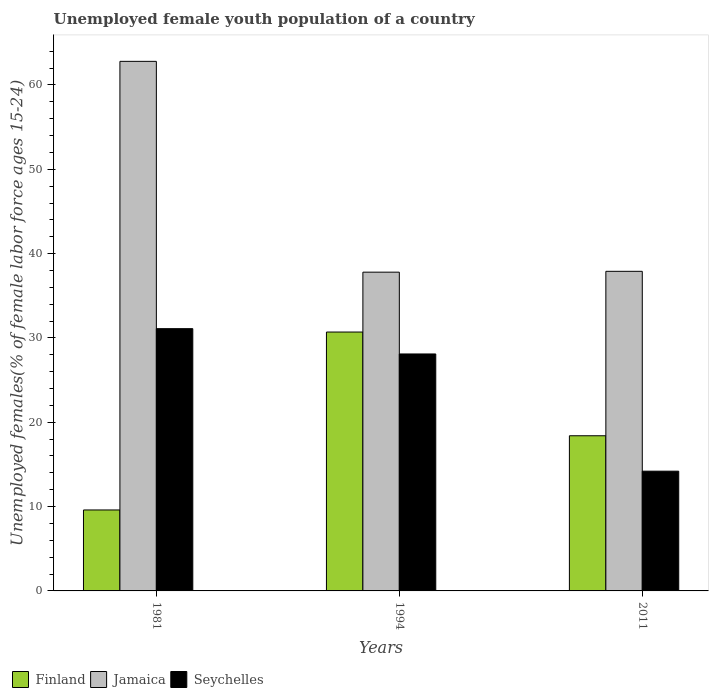How many bars are there on the 1st tick from the right?
Provide a short and direct response. 3. What is the label of the 2nd group of bars from the left?
Your answer should be compact. 1994. What is the percentage of unemployed female youth population in Finland in 1994?
Your answer should be compact. 30.7. Across all years, what is the maximum percentage of unemployed female youth population in Jamaica?
Your answer should be compact. 62.8. Across all years, what is the minimum percentage of unemployed female youth population in Jamaica?
Your response must be concise. 37.8. In which year was the percentage of unemployed female youth population in Jamaica maximum?
Make the answer very short. 1981. In which year was the percentage of unemployed female youth population in Finland minimum?
Give a very brief answer. 1981. What is the total percentage of unemployed female youth population in Jamaica in the graph?
Ensure brevity in your answer.  138.5. What is the difference between the percentage of unemployed female youth population in Finland in 1981 and that in 1994?
Provide a short and direct response. -21.1. What is the difference between the percentage of unemployed female youth population in Finland in 2011 and the percentage of unemployed female youth population in Jamaica in 1981?
Your response must be concise. -44.4. What is the average percentage of unemployed female youth population in Seychelles per year?
Ensure brevity in your answer.  24.47. In the year 1994, what is the difference between the percentage of unemployed female youth population in Seychelles and percentage of unemployed female youth population in Jamaica?
Provide a short and direct response. -9.7. In how many years, is the percentage of unemployed female youth population in Finland greater than 26 %?
Your response must be concise. 1. What is the ratio of the percentage of unemployed female youth population in Seychelles in 1981 to that in 1994?
Your response must be concise. 1.11. What is the difference between the highest and the second highest percentage of unemployed female youth population in Seychelles?
Provide a succinct answer. 3. What is the difference between the highest and the lowest percentage of unemployed female youth population in Finland?
Your answer should be very brief. 21.1. Is the sum of the percentage of unemployed female youth population in Finland in 1994 and 2011 greater than the maximum percentage of unemployed female youth population in Seychelles across all years?
Provide a short and direct response. Yes. What does the 2nd bar from the right in 2011 represents?
Ensure brevity in your answer.  Jamaica. Are the values on the major ticks of Y-axis written in scientific E-notation?
Ensure brevity in your answer.  No. Where does the legend appear in the graph?
Provide a short and direct response. Bottom left. What is the title of the graph?
Offer a very short reply. Unemployed female youth population of a country. What is the label or title of the X-axis?
Your answer should be very brief. Years. What is the label or title of the Y-axis?
Provide a short and direct response. Unemployed females(% of female labor force ages 15-24). What is the Unemployed females(% of female labor force ages 15-24) of Finland in 1981?
Your response must be concise. 9.6. What is the Unemployed females(% of female labor force ages 15-24) of Jamaica in 1981?
Keep it short and to the point. 62.8. What is the Unemployed females(% of female labor force ages 15-24) in Seychelles in 1981?
Your response must be concise. 31.1. What is the Unemployed females(% of female labor force ages 15-24) of Finland in 1994?
Your answer should be compact. 30.7. What is the Unemployed females(% of female labor force ages 15-24) in Jamaica in 1994?
Your answer should be very brief. 37.8. What is the Unemployed females(% of female labor force ages 15-24) in Seychelles in 1994?
Provide a short and direct response. 28.1. What is the Unemployed females(% of female labor force ages 15-24) in Finland in 2011?
Make the answer very short. 18.4. What is the Unemployed females(% of female labor force ages 15-24) in Jamaica in 2011?
Offer a very short reply. 37.9. What is the Unemployed females(% of female labor force ages 15-24) in Seychelles in 2011?
Provide a succinct answer. 14.2. Across all years, what is the maximum Unemployed females(% of female labor force ages 15-24) of Finland?
Your answer should be compact. 30.7. Across all years, what is the maximum Unemployed females(% of female labor force ages 15-24) in Jamaica?
Your answer should be very brief. 62.8. Across all years, what is the maximum Unemployed females(% of female labor force ages 15-24) of Seychelles?
Your answer should be compact. 31.1. Across all years, what is the minimum Unemployed females(% of female labor force ages 15-24) in Finland?
Provide a short and direct response. 9.6. Across all years, what is the minimum Unemployed females(% of female labor force ages 15-24) in Jamaica?
Keep it short and to the point. 37.8. Across all years, what is the minimum Unemployed females(% of female labor force ages 15-24) of Seychelles?
Ensure brevity in your answer.  14.2. What is the total Unemployed females(% of female labor force ages 15-24) in Finland in the graph?
Your answer should be very brief. 58.7. What is the total Unemployed females(% of female labor force ages 15-24) in Jamaica in the graph?
Offer a very short reply. 138.5. What is the total Unemployed females(% of female labor force ages 15-24) in Seychelles in the graph?
Ensure brevity in your answer.  73.4. What is the difference between the Unemployed females(% of female labor force ages 15-24) of Finland in 1981 and that in 1994?
Offer a terse response. -21.1. What is the difference between the Unemployed females(% of female labor force ages 15-24) in Jamaica in 1981 and that in 1994?
Give a very brief answer. 25. What is the difference between the Unemployed females(% of female labor force ages 15-24) in Finland in 1981 and that in 2011?
Offer a very short reply. -8.8. What is the difference between the Unemployed females(% of female labor force ages 15-24) in Jamaica in 1981 and that in 2011?
Offer a very short reply. 24.9. What is the difference between the Unemployed females(% of female labor force ages 15-24) in Seychelles in 1981 and that in 2011?
Ensure brevity in your answer.  16.9. What is the difference between the Unemployed females(% of female labor force ages 15-24) of Jamaica in 1994 and that in 2011?
Your answer should be very brief. -0.1. What is the difference between the Unemployed females(% of female labor force ages 15-24) in Seychelles in 1994 and that in 2011?
Provide a short and direct response. 13.9. What is the difference between the Unemployed females(% of female labor force ages 15-24) of Finland in 1981 and the Unemployed females(% of female labor force ages 15-24) of Jamaica in 1994?
Provide a short and direct response. -28.2. What is the difference between the Unemployed females(% of female labor force ages 15-24) in Finland in 1981 and the Unemployed females(% of female labor force ages 15-24) in Seychelles in 1994?
Ensure brevity in your answer.  -18.5. What is the difference between the Unemployed females(% of female labor force ages 15-24) of Jamaica in 1981 and the Unemployed females(% of female labor force ages 15-24) of Seychelles in 1994?
Your response must be concise. 34.7. What is the difference between the Unemployed females(% of female labor force ages 15-24) of Finland in 1981 and the Unemployed females(% of female labor force ages 15-24) of Jamaica in 2011?
Offer a very short reply. -28.3. What is the difference between the Unemployed females(% of female labor force ages 15-24) in Jamaica in 1981 and the Unemployed females(% of female labor force ages 15-24) in Seychelles in 2011?
Keep it short and to the point. 48.6. What is the difference between the Unemployed females(% of female labor force ages 15-24) of Finland in 1994 and the Unemployed females(% of female labor force ages 15-24) of Jamaica in 2011?
Ensure brevity in your answer.  -7.2. What is the difference between the Unemployed females(% of female labor force ages 15-24) of Jamaica in 1994 and the Unemployed females(% of female labor force ages 15-24) of Seychelles in 2011?
Your response must be concise. 23.6. What is the average Unemployed females(% of female labor force ages 15-24) in Finland per year?
Provide a short and direct response. 19.57. What is the average Unemployed females(% of female labor force ages 15-24) of Jamaica per year?
Make the answer very short. 46.17. What is the average Unemployed females(% of female labor force ages 15-24) in Seychelles per year?
Provide a short and direct response. 24.47. In the year 1981, what is the difference between the Unemployed females(% of female labor force ages 15-24) in Finland and Unemployed females(% of female labor force ages 15-24) in Jamaica?
Keep it short and to the point. -53.2. In the year 1981, what is the difference between the Unemployed females(% of female labor force ages 15-24) of Finland and Unemployed females(% of female labor force ages 15-24) of Seychelles?
Ensure brevity in your answer.  -21.5. In the year 1981, what is the difference between the Unemployed females(% of female labor force ages 15-24) of Jamaica and Unemployed females(% of female labor force ages 15-24) of Seychelles?
Ensure brevity in your answer.  31.7. In the year 1994, what is the difference between the Unemployed females(% of female labor force ages 15-24) of Finland and Unemployed females(% of female labor force ages 15-24) of Jamaica?
Offer a terse response. -7.1. In the year 1994, what is the difference between the Unemployed females(% of female labor force ages 15-24) of Finland and Unemployed females(% of female labor force ages 15-24) of Seychelles?
Provide a succinct answer. 2.6. In the year 2011, what is the difference between the Unemployed females(% of female labor force ages 15-24) in Finland and Unemployed females(% of female labor force ages 15-24) in Jamaica?
Keep it short and to the point. -19.5. In the year 2011, what is the difference between the Unemployed females(% of female labor force ages 15-24) of Jamaica and Unemployed females(% of female labor force ages 15-24) of Seychelles?
Your answer should be compact. 23.7. What is the ratio of the Unemployed females(% of female labor force ages 15-24) in Finland in 1981 to that in 1994?
Provide a succinct answer. 0.31. What is the ratio of the Unemployed females(% of female labor force ages 15-24) in Jamaica in 1981 to that in 1994?
Give a very brief answer. 1.66. What is the ratio of the Unemployed females(% of female labor force ages 15-24) in Seychelles in 1981 to that in 1994?
Offer a terse response. 1.11. What is the ratio of the Unemployed females(% of female labor force ages 15-24) of Finland in 1981 to that in 2011?
Provide a succinct answer. 0.52. What is the ratio of the Unemployed females(% of female labor force ages 15-24) in Jamaica in 1981 to that in 2011?
Give a very brief answer. 1.66. What is the ratio of the Unemployed females(% of female labor force ages 15-24) in Seychelles in 1981 to that in 2011?
Make the answer very short. 2.19. What is the ratio of the Unemployed females(% of female labor force ages 15-24) in Finland in 1994 to that in 2011?
Give a very brief answer. 1.67. What is the ratio of the Unemployed females(% of female labor force ages 15-24) in Seychelles in 1994 to that in 2011?
Give a very brief answer. 1.98. What is the difference between the highest and the second highest Unemployed females(% of female labor force ages 15-24) in Jamaica?
Keep it short and to the point. 24.9. What is the difference between the highest and the second highest Unemployed females(% of female labor force ages 15-24) in Seychelles?
Provide a succinct answer. 3. What is the difference between the highest and the lowest Unemployed females(% of female labor force ages 15-24) of Finland?
Ensure brevity in your answer.  21.1. What is the difference between the highest and the lowest Unemployed females(% of female labor force ages 15-24) in Seychelles?
Your response must be concise. 16.9. 